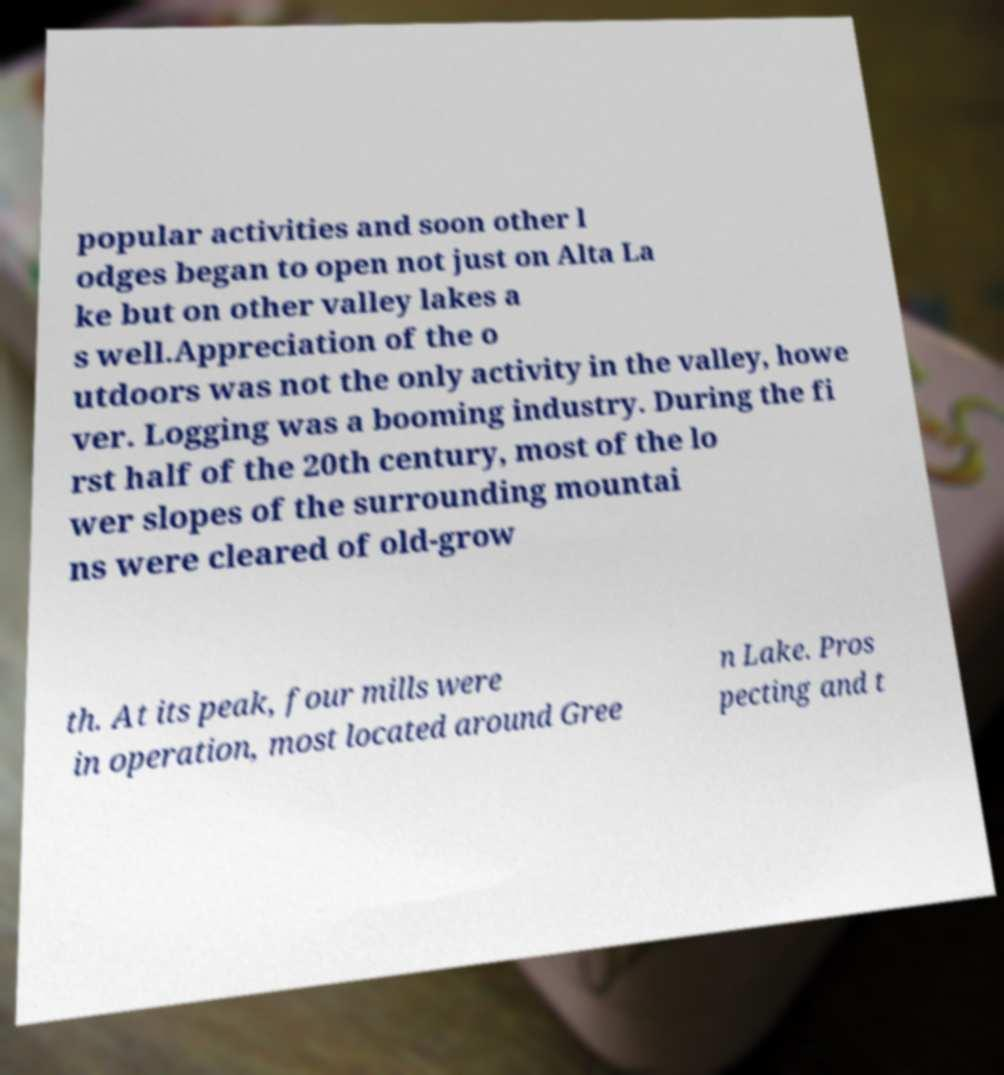For documentation purposes, I need the text within this image transcribed. Could you provide that? popular activities and soon other l odges began to open not just on Alta La ke but on other valley lakes a s well.Appreciation of the o utdoors was not the only activity in the valley, howe ver. Logging was a booming industry. During the fi rst half of the 20th century, most of the lo wer slopes of the surrounding mountai ns were cleared of old-grow th. At its peak, four mills were in operation, most located around Gree n Lake. Pros pecting and t 